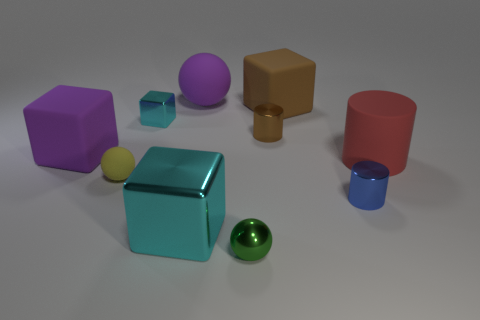Imagine these objects are part of a child's toy set. Which learning activity can you suggest with these? A learning activity could involve sorting the objects by color, shape, or size. For instance, children could group all similar shapes together or arrange the objects from largest to smallest, which helps develop their cognitive skills in differentiating and categorizing. 